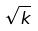<formula> <loc_0><loc_0><loc_500><loc_500>\sqrt { k }</formula> 